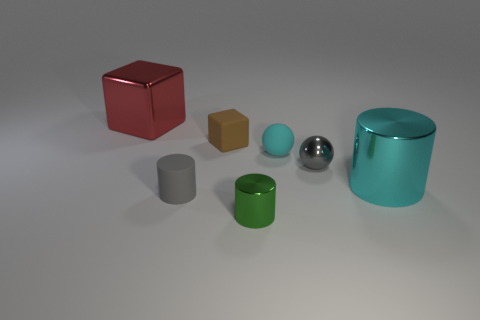The rubber cylinder is what size?
Your answer should be very brief. Small. Is the tiny cyan sphere made of the same material as the small gray ball?
Give a very brief answer. No. There is a cyan thing that is to the left of the big metal cylinder that is in front of the rubber block; what number of small cyan objects are behind it?
Ensure brevity in your answer.  0. The small shiny thing that is on the left side of the cyan rubber thing has what shape?
Your answer should be very brief. Cylinder. What number of other things are there of the same material as the green object
Your response must be concise. 3. Does the large metal cylinder have the same color as the rubber ball?
Make the answer very short. Yes. Is the number of tiny green shiny cylinders that are right of the tiny cyan object less than the number of big shiny objects that are in front of the big cyan metallic cylinder?
Your answer should be very brief. No. What color is the other small rubber object that is the same shape as the red object?
Provide a succinct answer. Brown. Does the metallic object that is in front of the cyan metallic cylinder have the same size as the red block?
Keep it short and to the point. No. Is the number of tiny gray matte objects that are right of the big red cube less than the number of large objects?
Make the answer very short. Yes. 